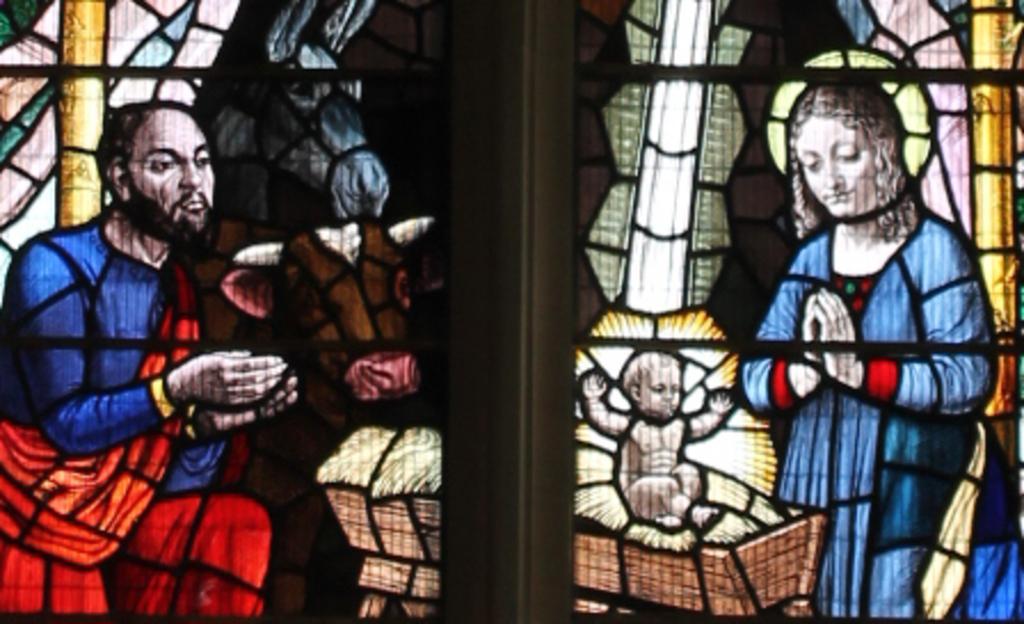Could you give a brief overview of what you see in this image? I see this is a depiction picture, where I can see a man, a woman, a baby and 2 animals. 